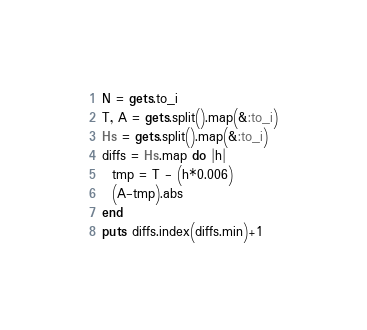<code> <loc_0><loc_0><loc_500><loc_500><_Ruby_>N = gets.to_i
T, A = gets.split().map(&:to_i)
Hs = gets.split().map(&:to_i)
diffs = Hs.map do |h|
  tmp = T - (h*0.006)
  (A-tmp).abs
end
puts diffs.index(diffs.min)+1
</code> 